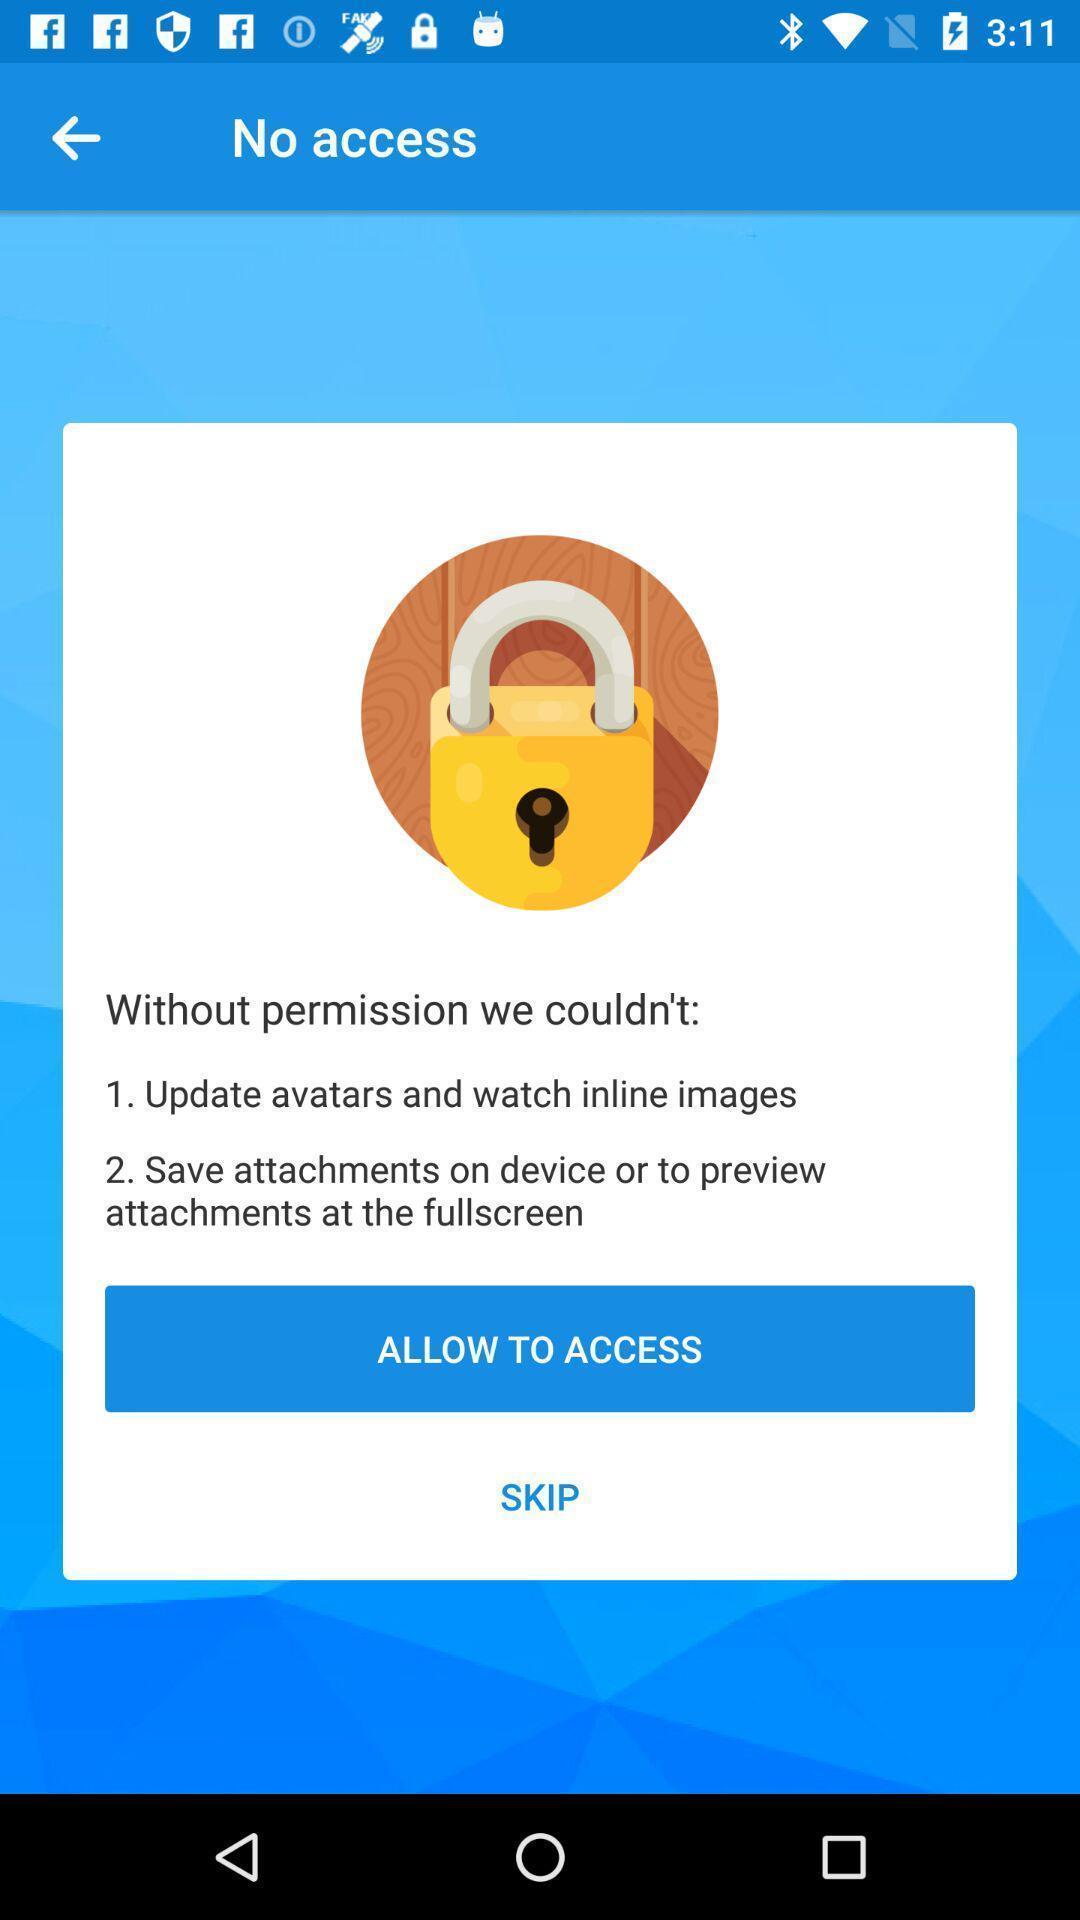Explain what's happening in this screen capture. Pop-up for permission to allow access or skip on app. 